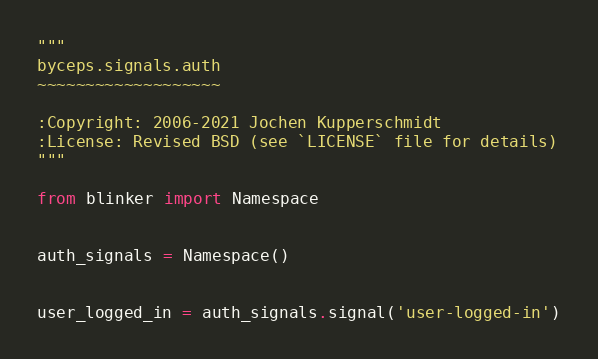Convert code to text. <code><loc_0><loc_0><loc_500><loc_500><_Python_>"""
byceps.signals.auth
~~~~~~~~~~~~~~~~~~~

:Copyright: 2006-2021 Jochen Kupperschmidt
:License: Revised BSD (see `LICENSE` file for details)
"""

from blinker import Namespace


auth_signals = Namespace()


user_logged_in = auth_signals.signal('user-logged-in')
</code> 